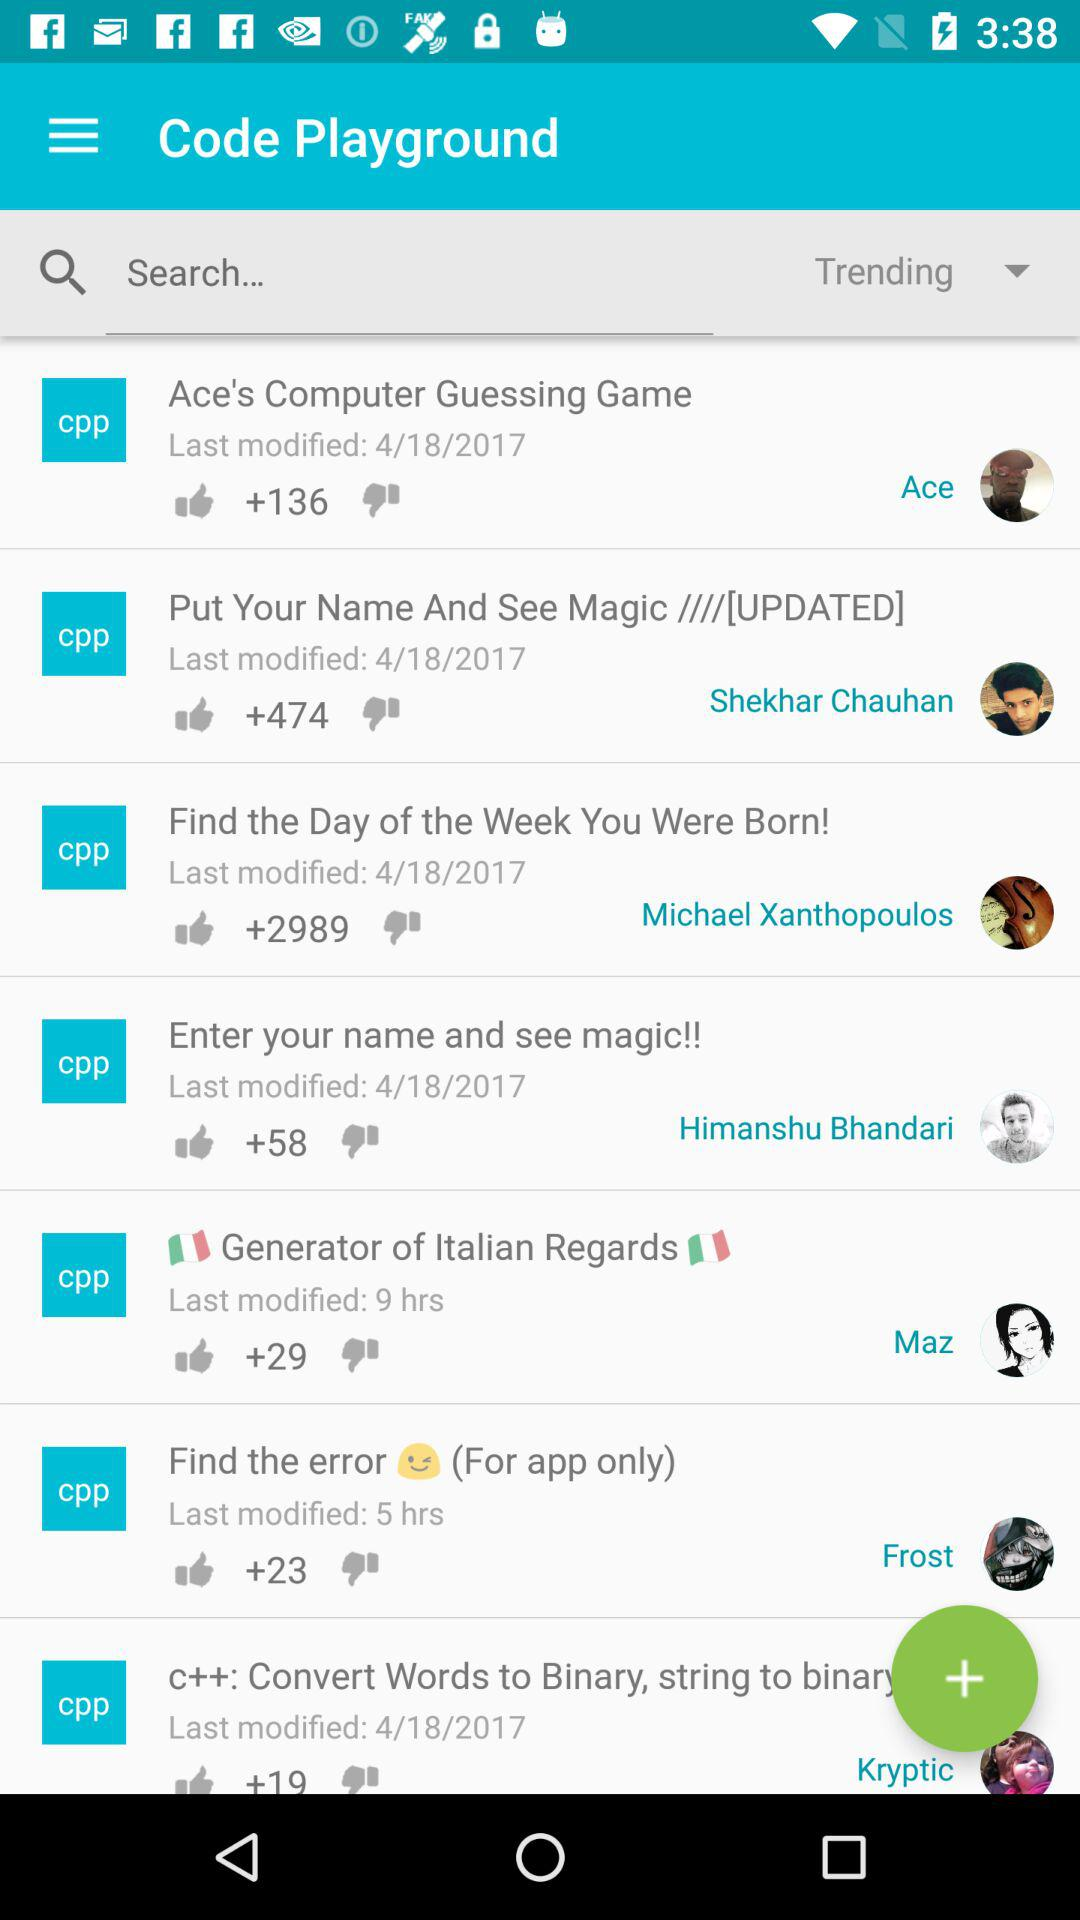What language are these projects coded in, and how can you tell? The projects in the image are coded in C++ as indicated by the 'cpp' tags on their respective tiles. This tag is a common abbreviation for C++ source files and represents the programming language used. 